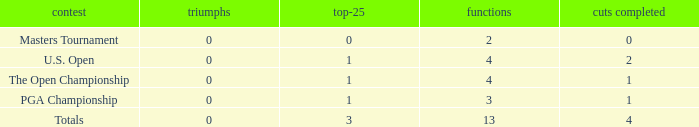Could you parse the entire table? {'header': ['contest', 'triumphs', 'top-25', 'functions', 'cuts completed'], 'rows': [['Masters Tournament', '0', '0', '2', '0'], ['U.S. Open', '0', '1', '4', '2'], ['The Open Championship', '0', '1', '4', '1'], ['PGA Championship', '0', '1', '3', '1'], ['Totals', '0', '3', '13', '4']]} How many cuts did he make at the PGA championship in 3 events? None. 